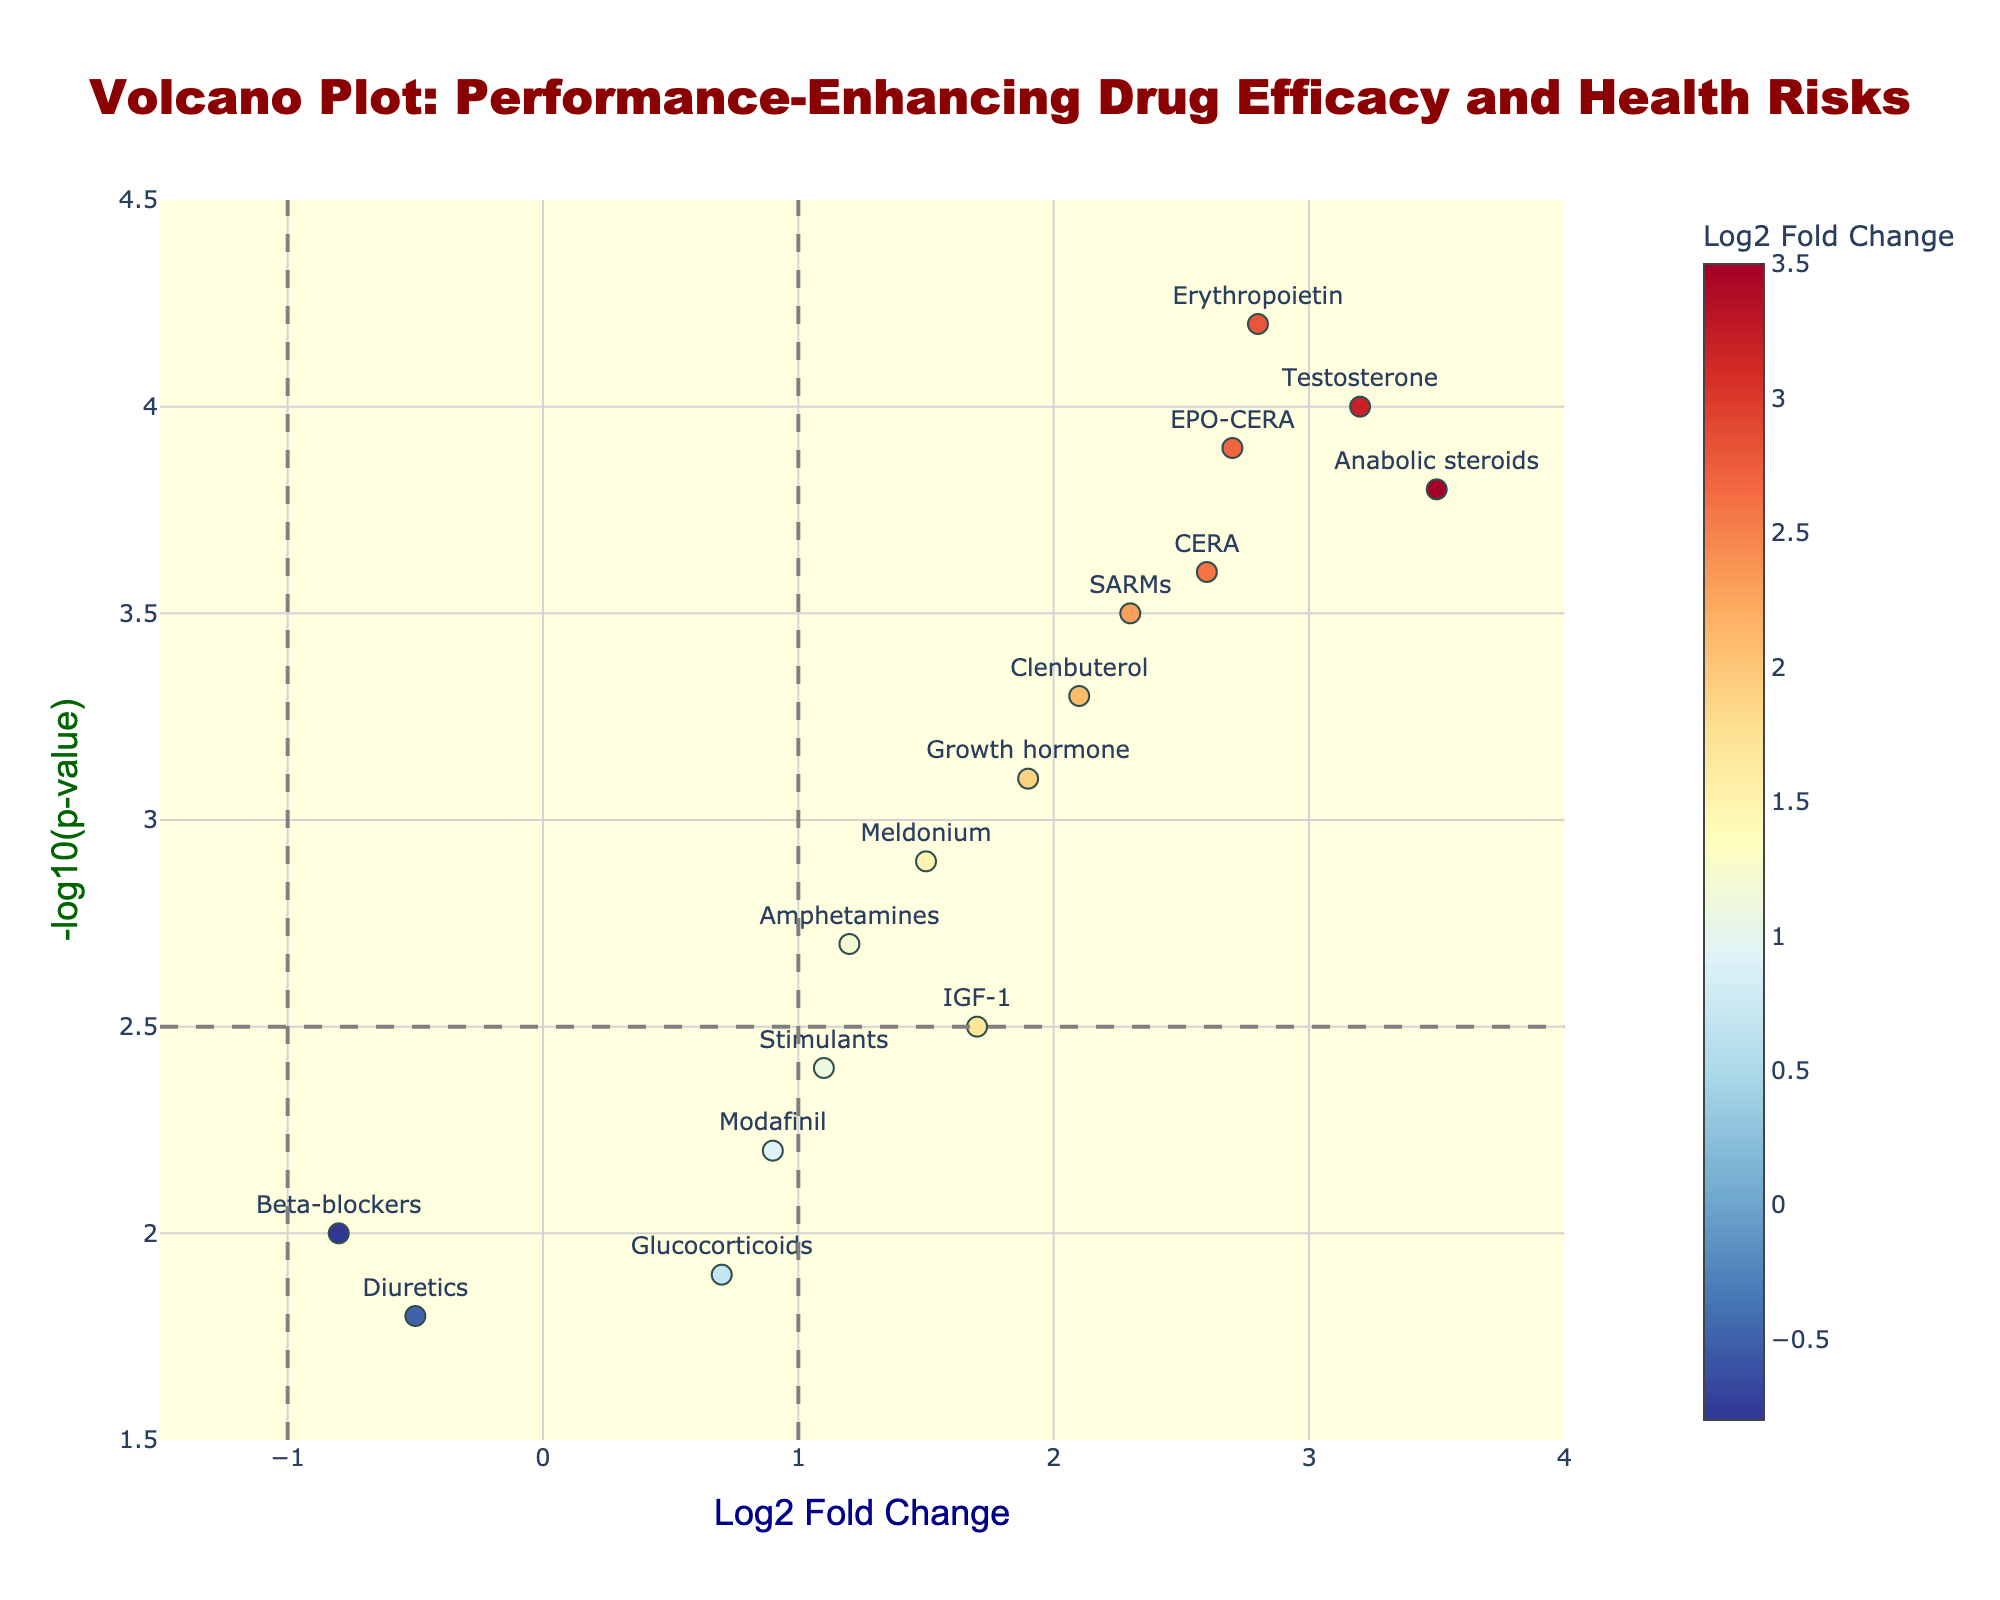What is the title of the figure? The title is located at the top center of the figure. It often provides a summary or subject of the plot.
Answer: Volcano Plot: Performance-Enhancing Drug Efficacy and Health Risks Which drug has the highest -log10(p-value)? By observing the figure, look for the point that is positioned highest on the y-axis which measures -log10(p-value).
Answer: Erythropoietin How many drugs have a Log2 Fold Change above 2? Identify and count the data points that fall to the right of the x-axis value of 2, which indicates a Log2 Fold Change greater than 2.
Answer: Six Between Testosterone and CERA, which drug has a higher -log10(p-value)? Locate the positions of Testosterone and CERA on the plot and compare their heights on the y-axis, which represents -log10(p-value).
Answer: Testosterone Which drugs are up-regulated and have significant p-values? Up-regulated drugs have a positive Log2 Fold Change. Significance is marked by crossing the horizontal line indicating a -log10(p-value) threshold of 2.5.
Answer: Erythropoietin, Anabolic steroids, Growth hormone, Clenbuterol, Testosterone, CERA, SARMs, EPO-CERA What is the Log2 Fold Change range of the data points? Identify the minimum and maximum Log2 Fold Change values on the x-axis. The minimum observed is -0.8 (Beta-blockers) and the maximum is 3.5 (Anabolic steroids).
Answer: -0.8 to 3.5 How many drugs have a -log10(p-value) below 2.0? Count the data points that fall below the 2.0 value on the y-axis.
Answer: Two Which drug has the smallest Log2 Fold Change, and what is its -log10(p-value)? Look at the left-most data point on the x-axis for the smallest Log2 Fold Change and then check its position on the y-axis for the -log10(p-value).
Answer: Beta-blockers, 2.0 What is the relationship between Meldonium and Modafinil in terms of Log2 Fold Change and -log10(p-value)? Compare the positions of Meldonium and Modafinil on both the x-axis and y-axis. Meldonium has higher Log2 Fold Change and a higher -log10(p-value) than Modafinil.
Answer: Meldonium has higher Log2 Fold Change and -log10(p-value) Identify all drugs with a Log2 Fold Change between 1.5 and 2.0. Look at the points located on the x-axis between 1.5 and 2.0 and list them.
Answer: Growth hormone, Meldonium, IGF-1 